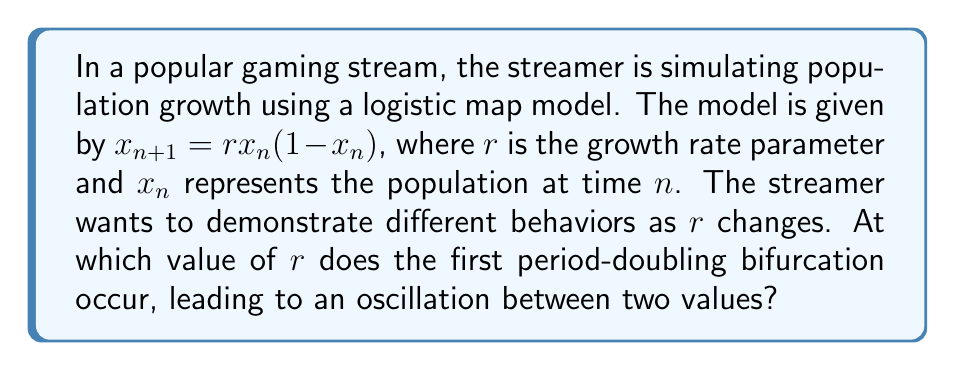Help me with this question. To find the first period-doubling bifurcation in the logistic map, we need to follow these steps:

1) The fixed points of the logistic map are found by solving $x = rx(1-x)$:
   $$x = 0$$ or $$x = 1 - \frac{1}{r}$$

2) The non-zero fixed point $x = 1 - \frac{1}{r}$ is stable when $|\frac{d}{dx}(rx(1-x))| < 1$ at $x = 1 - \frac{1}{r}$:

   $$|\frac{d}{dx}(rx(1-x))| = |r(1-2x)| < 1$$

3) Substituting $x = 1 - \frac{1}{r}$:

   $$|r(1-2(1-\frac{1}{r}))| = |r(1-2+\frac{2}{r})| = |2-r| < 1$$

4) This inequality holds for $1 < r < 3$.

5) At $r = 3$, the fixed point loses stability, and a period-2 cycle emerges. This is the first period-doubling bifurcation.

Therefore, the first period-doubling bifurcation occurs at $r = 3$.
Answer: $r = 3$ 